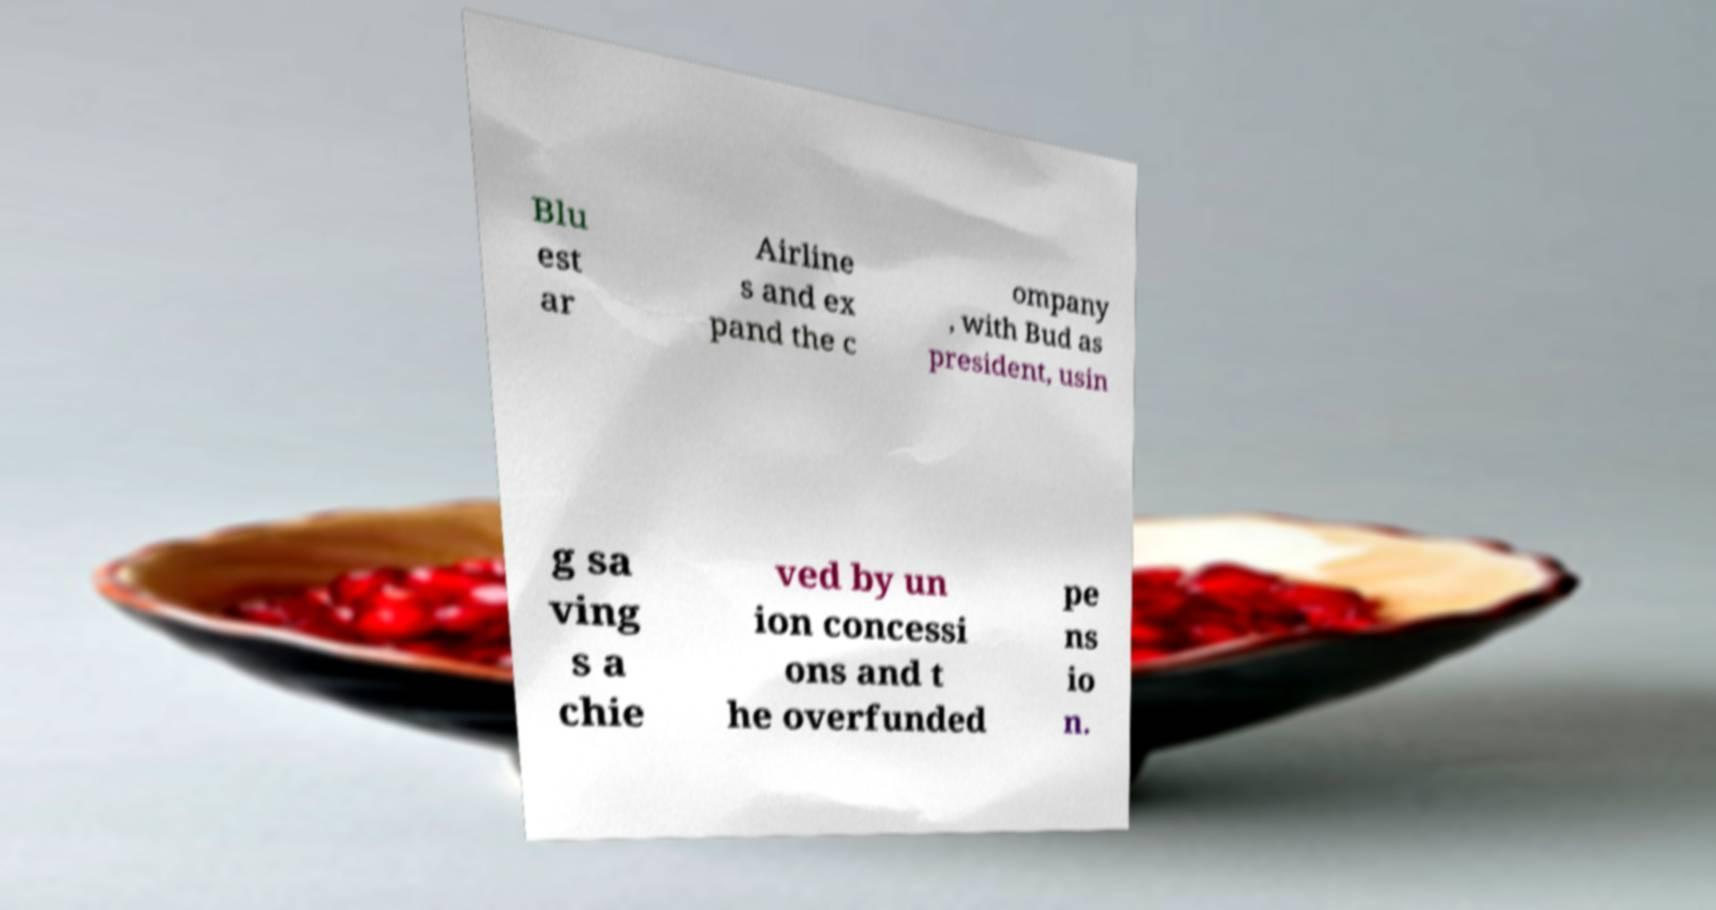Could you assist in decoding the text presented in this image and type it out clearly? Blu est ar Airline s and ex pand the c ompany , with Bud as president, usin g sa ving s a chie ved by un ion concessi ons and t he overfunded pe ns io n. 